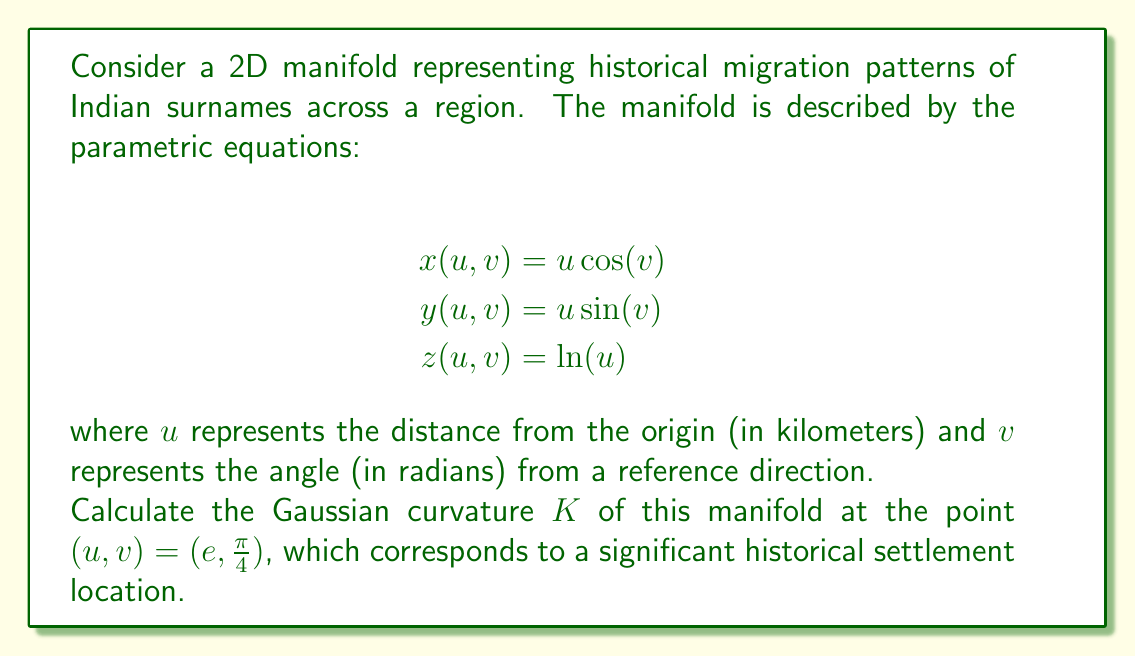What is the answer to this math problem? To calculate the Gaussian curvature of this 2D manifold, we'll follow these steps:

1) First, we need to calculate the coefficients of the first fundamental form (E, F, G) and the second fundamental form (L, M, N).

2) The first fundamental form coefficients are:
   $$E = x_u^2 + y_u^2 + z_u^2$$
   $$F = x_u x_v + y_u y_v + z_u z_v$$
   $$G = x_v^2 + y_v^2 + z_v^2$$

3) The second fundamental form coefficients are:
   $$L = \frac{x_{uu}n_x + y_{uu}n_y + z_{uu}n_z}{\sqrt{EG-F^2}}$$
   $$M = \frac{x_{uv}n_x + y_{uv}n_y + z_{uv}n_z}{\sqrt{EG-F^2}}$$
   $$N = \frac{x_{vv}n_x + y_{vv}n_y + z_{vv}n_z}{\sqrt{EG-F^2}}$$

   where $(n_x, n_y, n_z)$ is the unit normal vector to the surface.

4) Calculate the partial derivatives:
   $$x_u = \cos(v), \quad x_v = -u\sin(v)$$
   $$y_u = \sin(v), \quad y_v = u\cos(v)$$
   $$z_u = \frac{1}{u}, \quad z_v = 0$$

5) Calculate E, F, and G:
   $$E = \cos^2(v) + \sin^2(v) + \frac{1}{u^2} = 1 + \frac{1}{u^2}$$
   $$F = -u\sin(v)\cos(v) + u\sin(v)\cos(v) + 0 = 0$$
   $$G = u^2\sin^2(v) + u^2\cos^2(v) + 0 = u^2$$

6) Calculate the unit normal vector:
   $$\vec{n} = \frac{\vec{r_u} \times \vec{r_v}}{|\vec{r_u} \times \vec{r_v}|}$$
   $$= \frac{(-u\cos(v), -u\sin(v), 1)}{\sqrt{u^2\cos^2(v) + u^2\sin^2(v) + 1}}$$
   $$= \frac{(-u\cos(v), -u\sin(v), 1)}{\sqrt{u^2 + 1}}$$

7) Calculate the second partial derivatives:
   $$x_{uu} = 0, \quad x_{uv} = -\sin(v), \quad x_{vv} = -u\cos(v)$$
   $$y_{uu} = 0, \quad y_{uv} = \cos(v), \quad y_{vv} = -u\sin(v)$$
   $$z_{uu} = -\frac{1}{u^2}, \quad z_{uv} = 0, \quad z_{vv} = 0$$

8) Calculate L, M, and N:
   $$L = \frac{-\frac{1}{u^2}}{\sqrt{u^2 + 1}}$$
   $$M = 0$$
   $$N = \frac{-u}{\sqrt{u^2 + 1}}$$

9) The Gaussian curvature is given by:
   $$K = \frac{LN - M^2}{EG - F^2}$$

10) Substitute the values at the point $(u,v) = (e,\frac{\pi}{4})$:
    $$K = \frac{(-\frac{1}{e^2}\cdot\frac{-e}{\sqrt{e^2 + 1}}) - 0^2}{(1 + \frac{1}{e^2})(e^2) - 0^2}$$
    $$= \frac{\frac{1}{e\sqrt{e^2 + 1}}}{e^2 + 1}$$
    $$= \frac{1}{e(e^2 + 1)^{3/2}}$$

This is the Gaussian curvature at the specified point.
Answer: The Gaussian curvature $K$ at the point $(u,v) = (e,\frac{\pi}{4})$ is:

$$K = \frac{1}{e(e^2 + 1)^{3/2}} \approx 0.0406$$ 